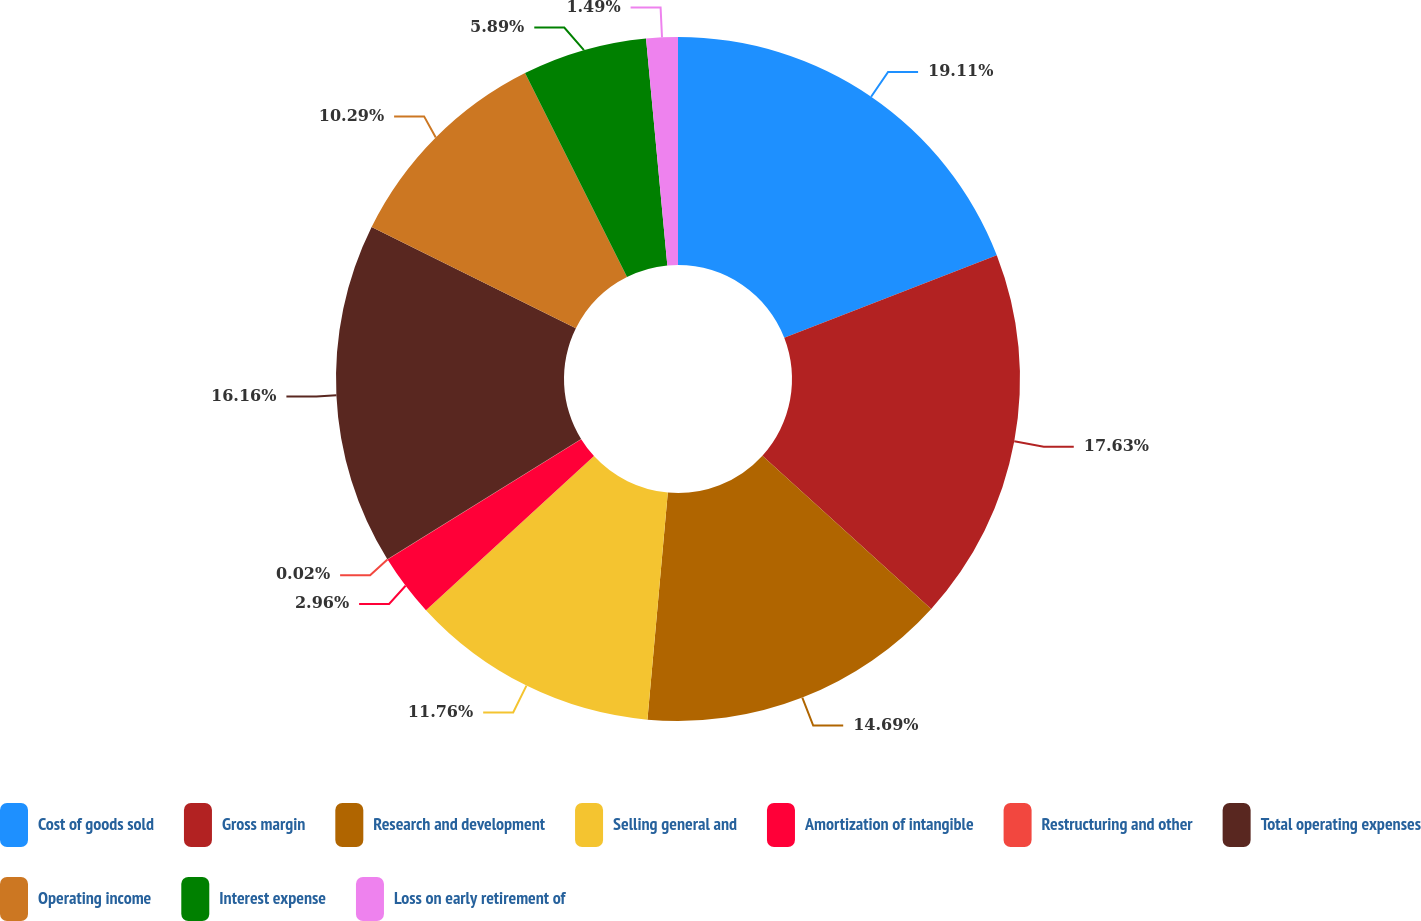Convert chart to OTSL. <chart><loc_0><loc_0><loc_500><loc_500><pie_chart><fcel>Cost of goods sold<fcel>Gross margin<fcel>Research and development<fcel>Selling general and<fcel>Amortization of intangible<fcel>Restructuring and other<fcel>Total operating expenses<fcel>Operating income<fcel>Interest expense<fcel>Loss on early retirement of<nl><fcel>19.1%<fcel>17.63%<fcel>14.69%<fcel>11.76%<fcel>2.96%<fcel>0.02%<fcel>16.16%<fcel>10.29%<fcel>5.89%<fcel>1.49%<nl></chart> 